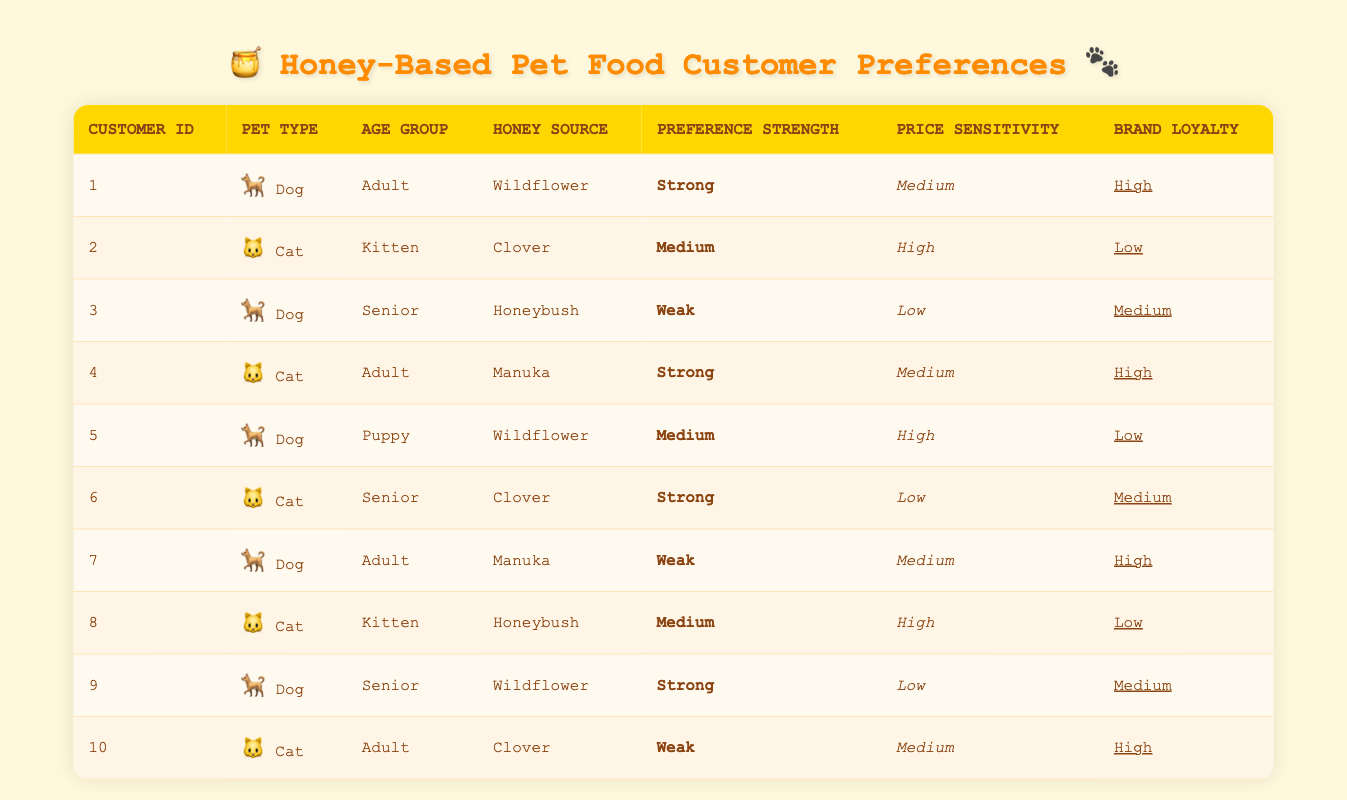What is the preference strength of customer ID 4? Customer ID 4 is listed as having a preference strength of "Strong" in the table. This information is found directly in the row corresponding to this customer.
Answer: Strong How many customers have high brand loyalty? A quick look at the table for brand loyalty shows that customers 1, 4, 7, and 10 have "High" brand loyalty. This totals to 4 customers.
Answer: 4 What is the average price sensitivity of the surveyed customers? The price sensitivities listed in the table are Medium, High, Low, Medium, High, Low, Medium, High, Low, and Medium. Assigning numeric values—Medium = 2, High = 3, Low = 1—results in (2 + 3 + 1 + 2 + 3 + 1 + 2 + 3 + 1 + 2) = 20. Then, dividing by 10 (the number of customers) gives an average of 2.
Answer: 2 Is there a customer who prefers wildflower honey and exhibits strong preference? Yes, customer ID 1 prefers wildflower honey and has a strong preference strength. This detail is directly observed in the respective row of the table.
Answer: Yes Which pet type has the highest number of customers showing strong preference? Filtering through the preferences, Dogs (customers 1 and 9) and Cats (customers 4 and 6) both show strong preference. Thus, both pet types have 2 customers each with a strong preference.
Answer: Both pet types have 2 customers with strong preference How many customers are cats that also prefer clover honey? Checking the table, customers 2 and 6 are both cats that prefer clover honey. Since there are only these two customers that match the criteria, the total is 2.
Answer: 2 Are there any senior dogs with weak preference strength? Yes, customer ID 3 is a senior dog with a weak preference strength, as listed in the table. This can be verified directly from the information provided.
Answer: Yes What is the total number of customers who have high price sensitivity? By reviewing the price sensitivity column, customers 2, 5, and 8 are identified as having high price sensitivity. This results in a total of 3 customers.
Answer: 3 